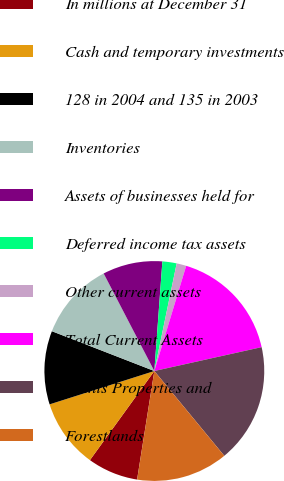Convert chart to OTSL. <chart><loc_0><loc_0><loc_500><loc_500><pie_chart><fcel>In millions at December 31<fcel>Cash and temporary investments<fcel>128 in 2004 and 135 in 2003<fcel>Inventories<fcel>Assets of businesses held for<fcel>Deferred income tax assets<fcel>Other current assets<fcel>Total Current Assets<fcel>Plants Properties and<fcel>Forestlands<nl><fcel>7.45%<fcel>10.13%<fcel>10.8%<fcel>11.47%<fcel>8.79%<fcel>2.09%<fcel>1.42%<fcel>16.83%<fcel>17.5%<fcel>13.48%<nl></chart> 